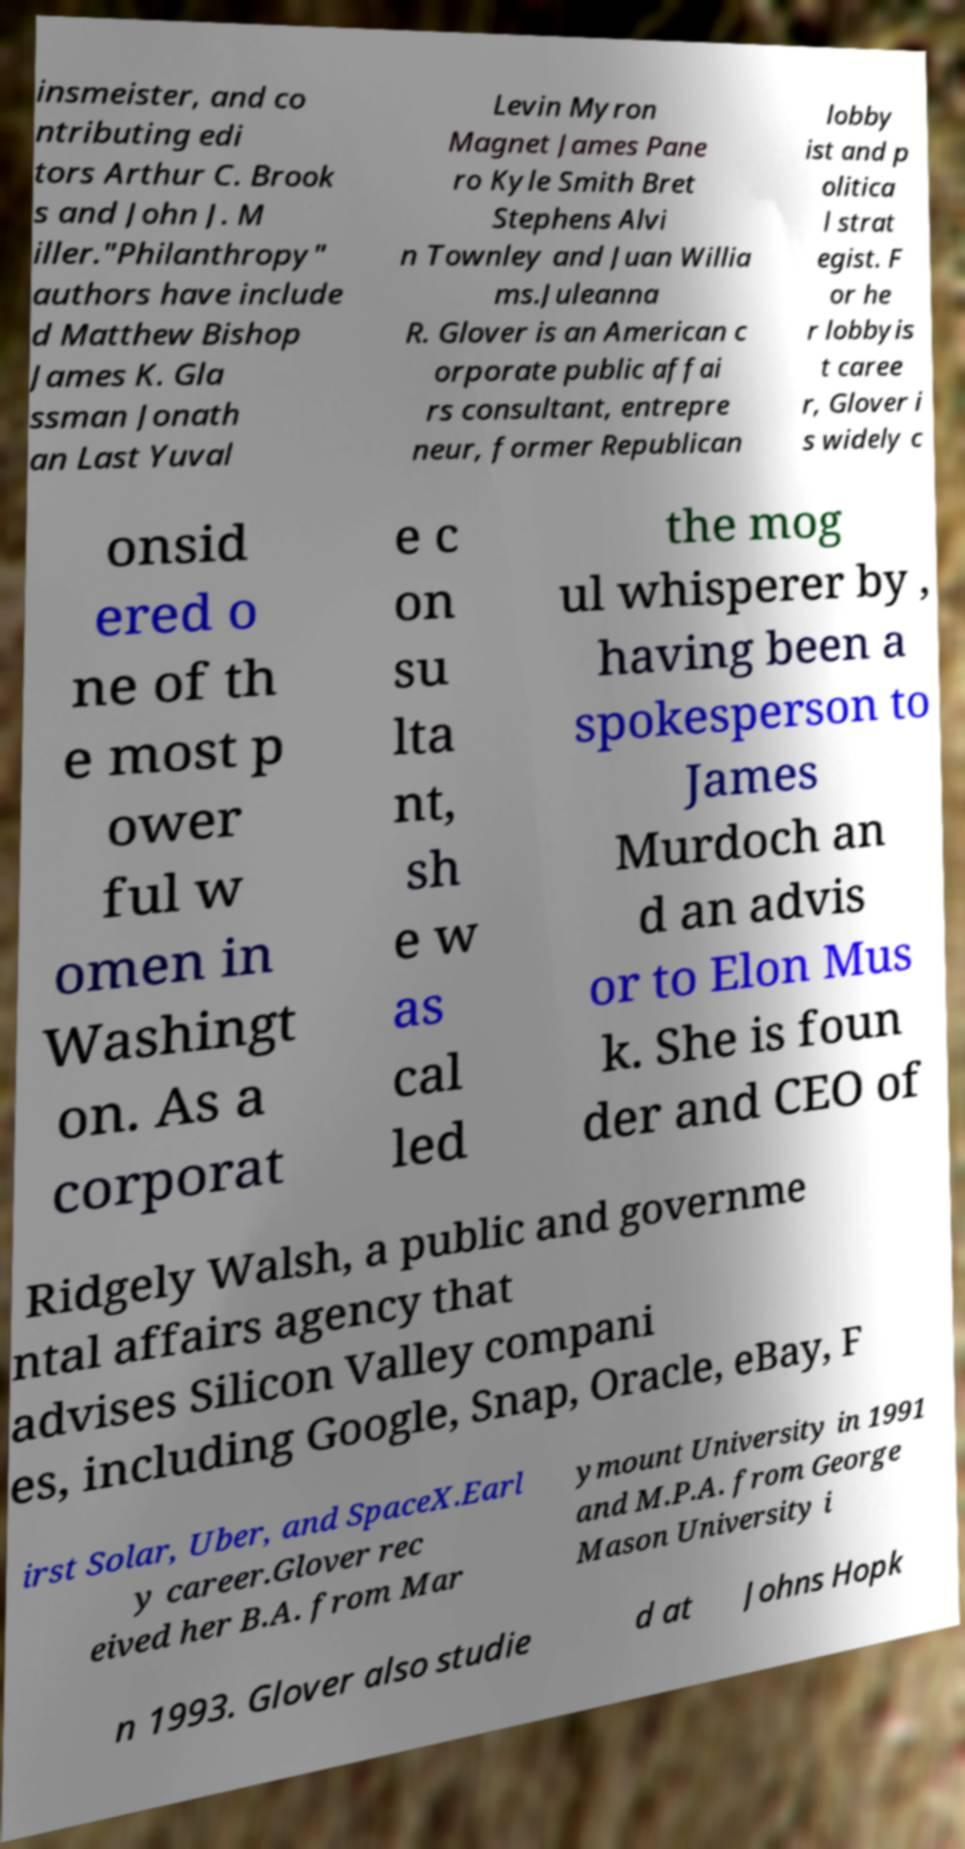There's text embedded in this image that I need extracted. Can you transcribe it verbatim? insmeister, and co ntributing edi tors Arthur C. Brook s and John J. M iller."Philanthropy" authors have include d Matthew Bishop James K. Gla ssman Jonath an Last Yuval Levin Myron Magnet James Pane ro Kyle Smith Bret Stephens Alvi n Townley and Juan Willia ms.Juleanna R. Glover is an American c orporate public affai rs consultant, entrepre neur, former Republican lobby ist and p olitica l strat egist. F or he r lobbyis t caree r, Glover i s widely c onsid ered o ne of th e most p ower ful w omen in Washingt on. As a corporat e c on su lta nt, sh e w as cal led the mog ul whisperer by , having been a spokesperson to James Murdoch an d an advis or to Elon Mus k. She is foun der and CEO of Ridgely Walsh, a public and governme ntal affairs agency that advises Silicon Valley compani es, including Google, Snap, Oracle, eBay, F irst Solar, Uber, and SpaceX.Earl y career.Glover rec eived her B.A. from Mar ymount University in 1991 and M.P.A. from George Mason University i n 1993. Glover also studie d at Johns Hopk 